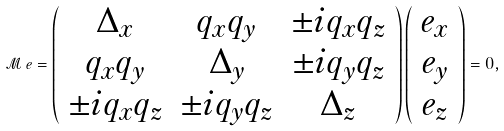Convert formula to latex. <formula><loc_0><loc_0><loc_500><loc_500>\mathcal { M } \, e = \left ( \begin{array} { c c c } \Delta _ { x } & q _ { x } q _ { y } & \pm i q _ { x } q _ { z } \\ q _ { x } q _ { y } & \Delta _ { y } & \pm i q _ { y } q _ { z } \\ \pm i q _ { x } q _ { z } & \pm i q _ { y } q _ { z } & \Delta _ { z } \end{array} \right ) \left ( \begin{array} { c c c } e _ { x } \\ e _ { y } \\ e _ { z } \end{array} \right ) = 0 ,</formula> 